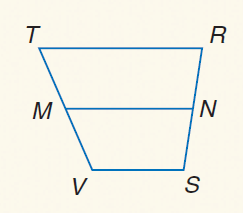Question: For trapezoid T R S V, M and N are midpoints of the legs. If V S = 21 and T R = 44, find M N.
Choices:
A. 21
B. 32.5
C. 44
D. 65
Answer with the letter. Answer: B 